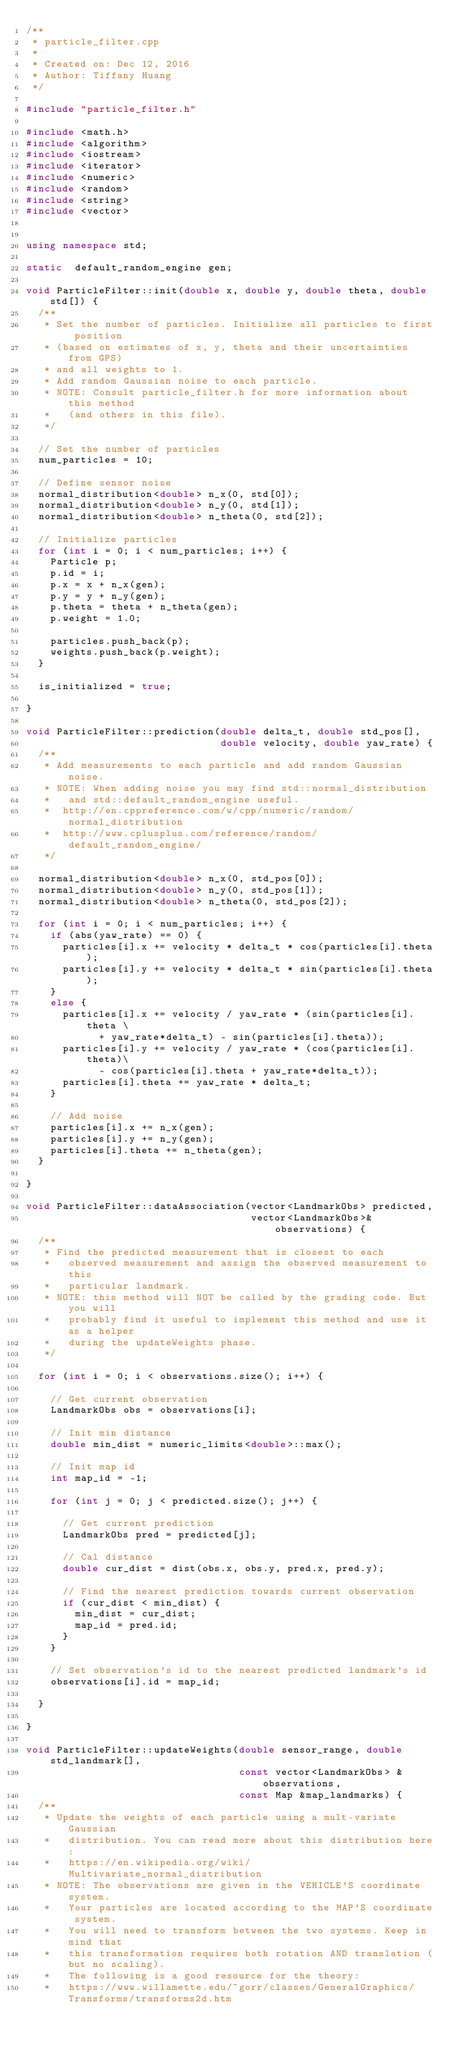Convert code to text. <code><loc_0><loc_0><loc_500><loc_500><_C++_>/**
 * particle_filter.cpp
 *
 * Created on: Dec 12, 2016
 * Author: Tiffany Huang
 */

#include "particle_filter.h"

#include <math.h>
#include <algorithm>
#include <iostream>
#include <iterator>
#include <numeric>
#include <random>
#include <string>
#include <vector>


using namespace std;

static  default_random_engine gen;

void ParticleFilter::init(double x, double y, double theta, double std[]) {
  /**
   * Set the number of particles. Initialize all particles to first position  
   * (based on estimates of x, y, theta and their uncertainties from GPS) 
   * and all weights to 1. 
   * Add random Gaussian noise to each particle.
   * NOTE: Consult particle_filter.h for more information about this method 
   *   (and others in this file).
   */

  // Set the number of particles
  num_particles = 10;  

  // Define sensor noise
  normal_distribution<double> n_x(0, std[0]);
  normal_distribution<double> n_y(0, std[1]);
  normal_distribution<double> n_theta(0, std[2]);

  // Initialize particles
  for (int i = 0; i < num_particles; i++) {
    Particle p;
    p.id = i;
    p.x = x + n_x(gen);
    p.y = y + n_y(gen);
    p.theta = theta + n_theta(gen);
    p.weight = 1.0;

    particles.push_back(p);
    weights.push_back(p.weight);
  }

  is_initialized = true;

}

void ParticleFilter::prediction(double delta_t, double std_pos[], 
                                double velocity, double yaw_rate) {
  /**
   * Add measurements to each particle and add random Gaussian noise.
   * NOTE: When adding noise you may find std::normal_distribution 
   *   and std::default_random_engine useful.
   *  http://en.cppreference.com/w/cpp/numeric/random/normal_distribution
   *  http://www.cplusplus.com/reference/random/default_random_engine/
   */

  normal_distribution<double> n_x(0, std_pos[0]);
  normal_distribution<double> n_y(0, std_pos[1]);
  normal_distribution<double> n_theta(0, std_pos[2]);

  for (int i = 0; i < num_particles; i++) {
    if (abs(yaw_rate) == 0) {
      particles[i].x += velocity * delta_t * cos(particles[i].theta);
      particles[i].y += velocity * delta_t * sin(particles[i].theta);
    }
    else {
      particles[i].x += velocity / yaw_rate * (sin(particles[i].theta \
            + yaw_rate*delta_t) - sin(particles[i].theta));
      particles[i].y += velocity / yaw_rate * (cos(particles[i].theta)\
            - cos(particles[i].theta + yaw_rate*delta_t));
      particles[i].theta += yaw_rate * delta_t;
    }

    // Add noise
    particles[i].x += n_x(gen);
    particles[i].y += n_y(gen);
    particles[i].theta += n_theta(gen);
  }

}

void ParticleFilter::dataAssociation(vector<LandmarkObs> predicted, 
                                     vector<LandmarkObs>& observations) {
  /**
   * Find the predicted measurement that is closest to each 
   *   observed measurement and assign the observed measurement to this 
   *   particular landmark.
   * NOTE: this method will NOT be called by the grading code. But you will 
   *   probably find it useful to implement this method and use it as a helper 
   *   during the updateWeights phase.
   */

  for (int i = 0; i < observations.size(); i++) {
    
    // Get current observation
    LandmarkObs obs = observations[i];

    // Init min distance
    double min_dist = numeric_limits<double>::max();

    // Init map id
    int map_id = -1;

    for (int j = 0; j < predicted.size(); j++) {
      
      // Get current prediction
      LandmarkObs pred = predicted[j];

      // Cal distance
      double cur_dist = dist(obs.x, obs.y, pred.x, pred.y);

      // Find the nearest prediction towards current observation
      if (cur_dist < min_dist) {
        min_dist = cur_dist;
        map_id = pred.id;
      }
    }

    // Set observation's id to the nearest predicted landmark's id
    observations[i].id = map_id;
    
  }

}

void ParticleFilter::updateWeights(double sensor_range, double std_landmark[], 
                                   const vector<LandmarkObs> &observations, 
                                   const Map &map_landmarks) {
  /**
   * Update the weights of each particle using a mult-variate Gaussian 
   *   distribution. You can read more about this distribution here: 
   *   https://en.wikipedia.org/wiki/Multivariate_normal_distribution
   * NOTE: The observations are given in the VEHICLE'S coordinate system. 
   *   Your particles are located according to the MAP'S coordinate system. 
   *   You will need to transform between the two systems. Keep in mind that
   *   this transformation requires both rotation AND translation (but no scaling).
   *   The following is a good resource for the theory:
   *   https://www.willamette.edu/~gorr/classes/GeneralGraphics/Transforms/transforms2d.htm</code> 